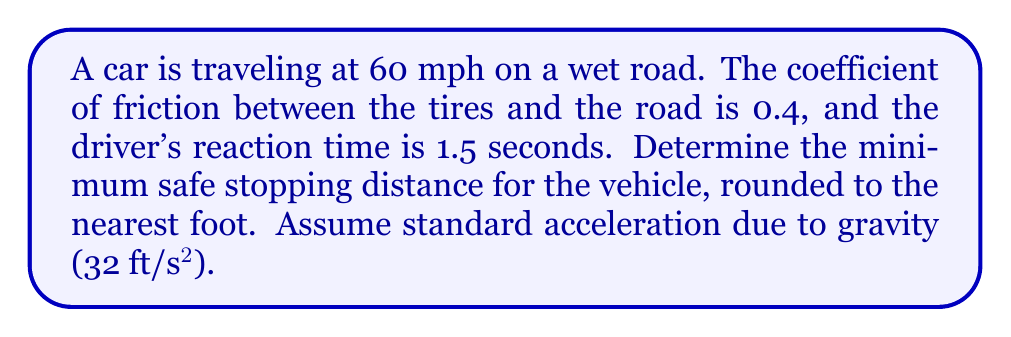Can you solve this math problem? To solve this problem, we need to calculate the total stopping distance, which is the sum of the reaction distance and the braking distance.

Step 1: Convert speed from mph to ft/s
$60 \text{ mph} = 60 \times \frac{5280 \text{ ft}}{3600 \text{ s}} = 88 \text{ ft/s}$

Step 2: Calculate the reaction distance
Reaction distance = Speed × Reaction time
$d_r = 88 \text{ ft/s} \times 1.5 \text{ s} = 132 \text{ ft}$

Step 3: Calculate the braking distance
Use the equation: $d_b = \frac{v^2}{2\mu g}$
Where:
$d_b$ = braking distance
$v$ = velocity (88 ft/s)
$\mu$ = coefficient of friction (0.4)
$g$ = acceleration due to gravity (32 ft/s²)

$d_b = \frac{(88 \text{ ft/s})^2}{2 \times 0.4 \times 32 \text{ ft/s}^2} = 242 \text{ ft}$

Step 4: Calculate the total stopping distance
Total stopping distance = Reaction distance + Braking distance
$d_{\text{total}} = 132 \text{ ft} + 242 \text{ ft} = 374 \text{ ft}$

Step 5: Round to the nearest foot
$374 \text{ ft}$ rounded to the nearest foot is $374 \text{ ft}$

Therefore, the minimum safe stopping distance for the vehicle is 374 feet.
Answer: 374 ft 